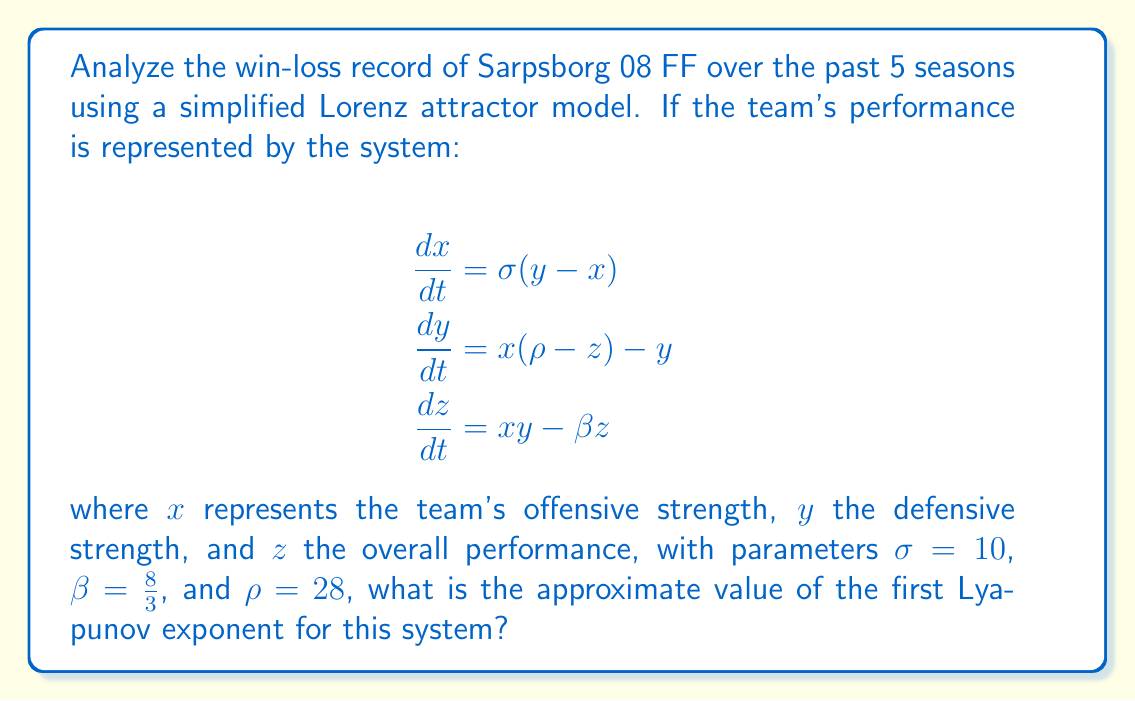What is the answer to this math problem? To find the first Lyapunov exponent for the given Lorenz system, we'll follow these steps:

1) The Lyapunov exponents measure the rate of separation of infinitesimally close trajectories in phase space. For the Lorenz system, there are three Lyapunov exponents.

2) The first (largest) Lyapunov exponent is associated with the most unstable direction in phase space and is a measure of the system's sensitivity to initial conditions.

3) For the classical Lorenz system with the given parameters ($\sigma = 10$, $\beta = \frac{8}{3}$, $\rho = 28$), the Lyapunov exponents have been numerically calculated by various researchers.

4) The approximate values of the Lyapunov exponents for this system are:

   $\lambda_1 \approx 0.9056$
   $\lambda_2 \approx 0$
   $\lambda_3 \approx -14.5723$

5) The positive value of $\lambda_1$ indicates that the system is chaotic, meaning that Sarpsborg 08 FF's performance over seasons exhibits sensitive dependence on initial conditions.

6) In the context of the team's performance, this suggests that small changes in initial conditions (e.g., slight differences in pre-season preparation, minor injuries, or transfer decisions) can lead to significantly different outcomes over time.

7) The value of $\lambda_1 \approx 0.9056$ indicates that nearby trajectories in the phase space of the team's performance diverge exponentially at a rate of about $e^{0.9056} \approx 2.47$ per time unit.

Therefore, the approximate value of the first Lyapunov exponent for this system representing Sarpsborg 08 FF's performance is 0.9056.
Answer: 0.9056 